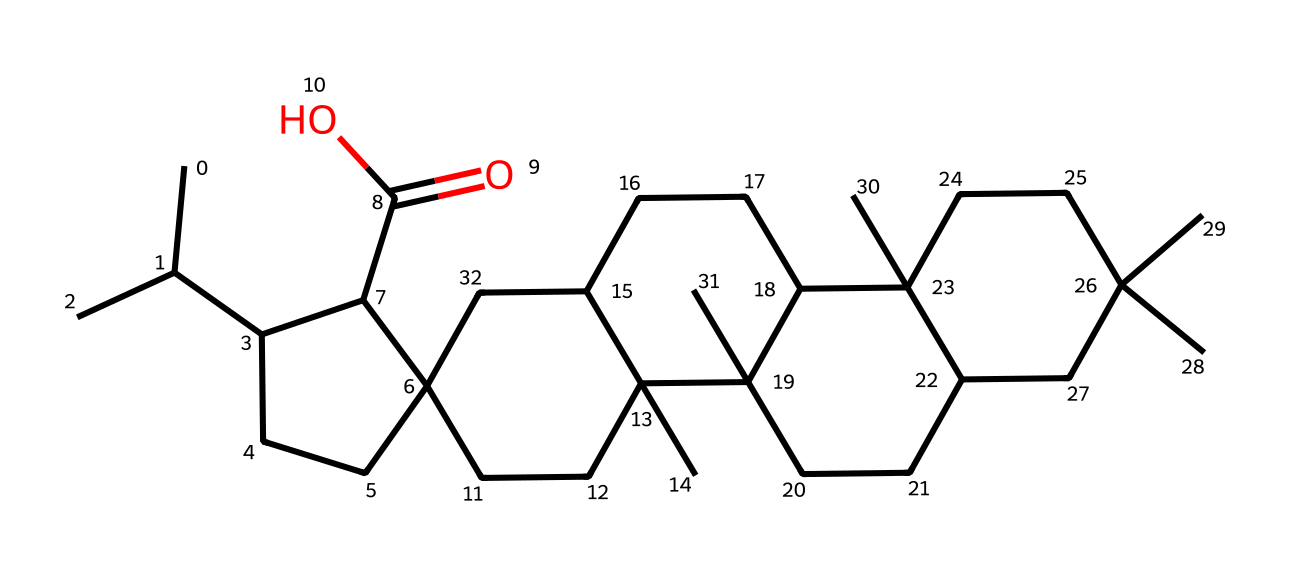What is the molecular formula of this compound? To determine the molecular formula, we need to count the number of each type of atom in the SMILES representation. The structure shows a total of 30 carbons (C), 50 hydrogens (H), and 2 oxygens (O). Therefore, the molecular formula is C30H50O2.
Answer: C30H50O2 How many rings are present in this chemical structure? By analyzing the structure, we can identify the number of closed-loop formations, known as rings. In the SMILES, we see multiple instances of numbers indicating bonds that connect to form rings. There are a total of 4 rings present in this chemical structure.
Answer: 4 What functional group is present in this compound? The SMILES notation contains "C(=O)O", indicating the presence of a carboxylic acid functional group. This is characterized by the carbon atom double-bonded to oxygen and single-bonded to a hydroxyl group (OH).
Answer: carboxylic acid Which part of the molecule contributes to its photoreactivity? In photoreactive chemicals, conjugated systems or specific functional groups often contribute to light absorption and reactivity. In this case, the presence of the double bond in the carboxylic acid group and the aromatic nature of the rings indicate regions that contribute to photoreactivity due to potential π-π* transitions.
Answer: carboxylic acid and rings What is the main component of rosin used in violin bows? The main component of rosin is typically a mixture of various resin acids, especially abietic acid. Based on the structure represented in the SMILES, the presence of a carboxylic acid indicates that it closely relates to resin acids, which are primary components of rosin.
Answer: resin acids 